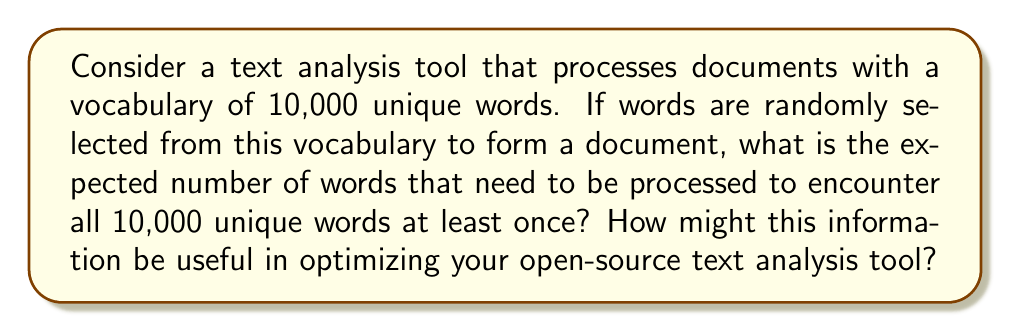Show me your answer to this math problem. To solve this problem, we can use the coupon collector's problem from probability theory. Let's approach this step-by-step:

1) In the coupon collector's problem, the expected number of trials to collect all $n$ coupons is given by:

   $$E[T] = n \sum_{i=1}^n \frac{1}{i}$$

   Where $n$ is the total number of unique items (in this case, words).

2) In our problem, $n = 10,000$.

3) We need to calculate:

   $$E[T] = 10000 \sum_{i=1}^{10000} \frac{1}{i}$$

4) The sum $\sum_{i=1}^n \frac{1}{i}$ is known as the $n$-th harmonic number, often denoted as $H_n$.

5) For large $n$, we can approximate $H_n$ using the natural logarithm:

   $$H_n \approx \ln(n) + \gamma$$

   Where $\gamma \approx 0.5772156649$ is the Euler-Mascheroni constant.

6) Applying this approximation:

   $$E[T] \approx 10000 (\ln(10000) + \gamma)$$

7) Calculating:
   
   $$E[T] \approx 10000 (9.21034 + 0.5772156649) \approx 97,875$$

This result suggests that, on average, you would need to process about 97,875 words to encounter all 10,000 unique words at least once.

For a software engineer developing open-source text analysis tools, this information could be valuable in several ways:
- Estimating the minimum document size needed for comprehensive vocabulary analysis
- Optimizing memory allocation for unique word storage in large documents
- Designing efficient algorithms for vocabulary saturation analysis
- Setting expectations for vocabulary coverage in document summarization tasks
Answer: 97,875 words 